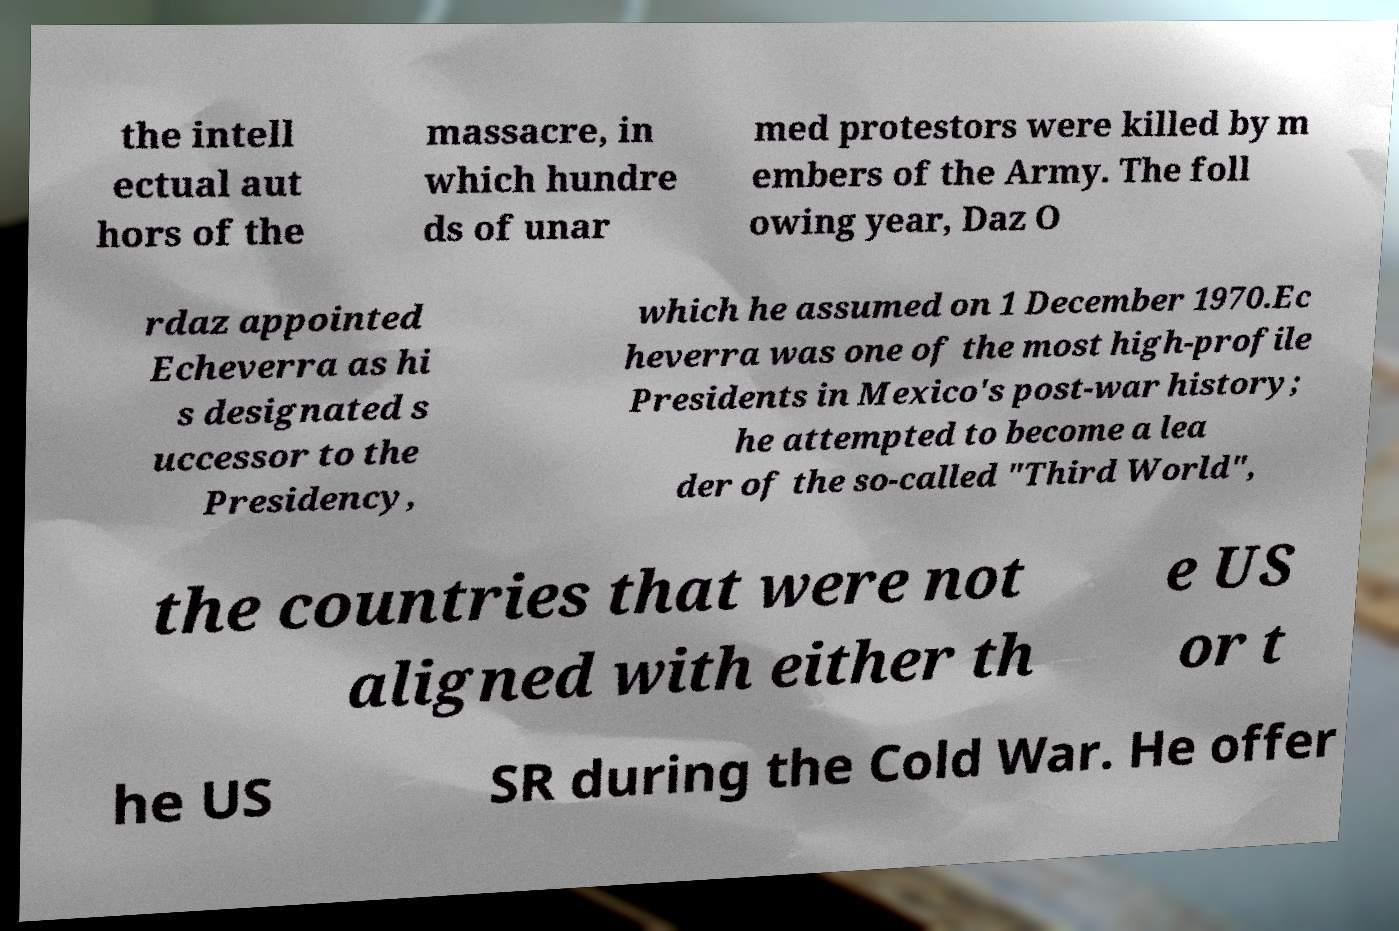Could you extract and type out the text from this image? the intell ectual aut hors of the massacre, in which hundre ds of unar med protestors were killed by m embers of the Army. The foll owing year, Daz O rdaz appointed Echeverra as hi s designated s uccessor to the Presidency, which he assumed on 1 December 1970.Ec heverra was one of the most high-profile Presidents in Mexico's post-war history; he attempted to become a lea der of the so-called "Third World", the countries that were not aligned with either th e US or t he US SR during the Cold War. He offer 